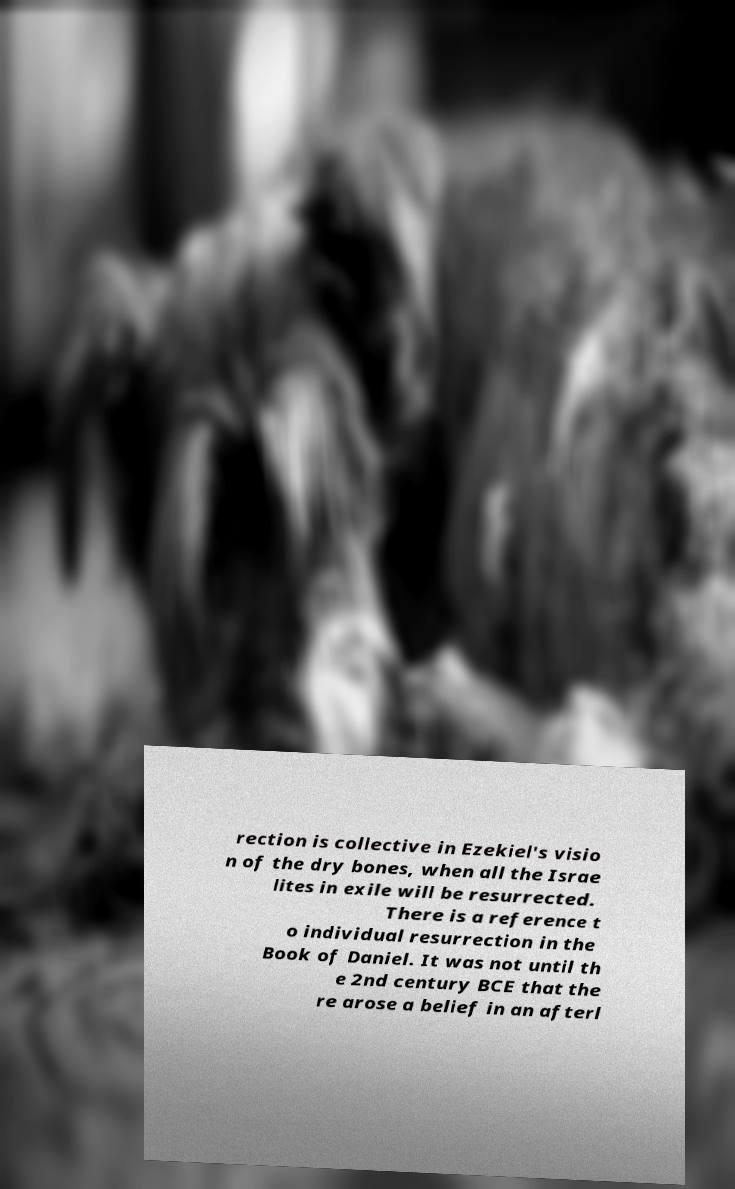Can you accurately transcribe the text from the provided image for me? rection is collective in Ezekiel's visio n of the dry bones, when all the Israe lites in exile will be resurrected. There is a reference t o individual resurrection in the Book of Daniel. It was not until th e 2nd century BCE that the re arose a belief in an afterl 